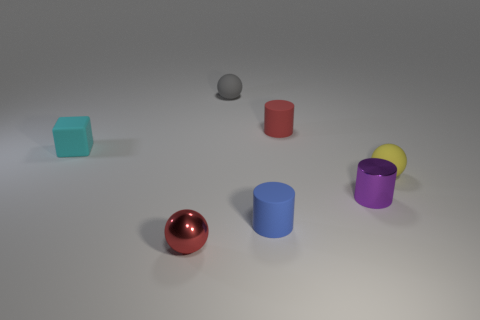Imagine if these objects were characters in a story, what kind of setting do they evoke? If these objects were characters in a story, they might evoke a setting in a modern, minimalist world. The simplicity of their shapes and the smoothness of their surfaces suggest a clean, organized environment where each character has its unique personality and role. What interactions can you picture between these objects if they were characters? I can imagine the red sphere being the dynamic leader, often rolling around to gather the others for meetings. The blue cylinder might be the dependable one, always standing tall and supporting its friends. The purple cylinder could be seen as the creative spirit, while the teal cube might be the curious explorer of the group. Their interactions would be cooperative, each contributing with their distinctive traits. 